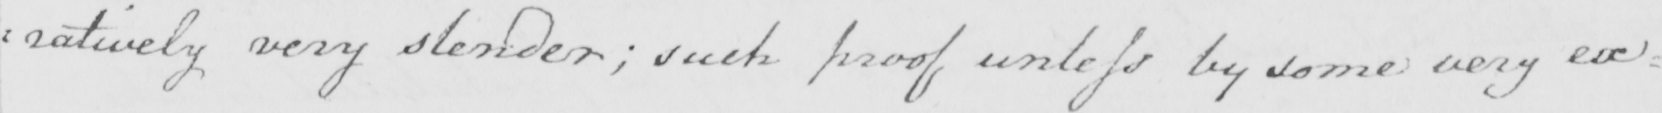What text is written in this handwritten line? : ratively very slender  ; such proof unless by some very ex= 